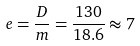Convert formula to latex. <formula><loc_0><loc_0><loc_500><loc_500>e = \frac { D } { m } = \frac { 1 3 0 } { 1 8 . 6 } \approx 7</formula> 